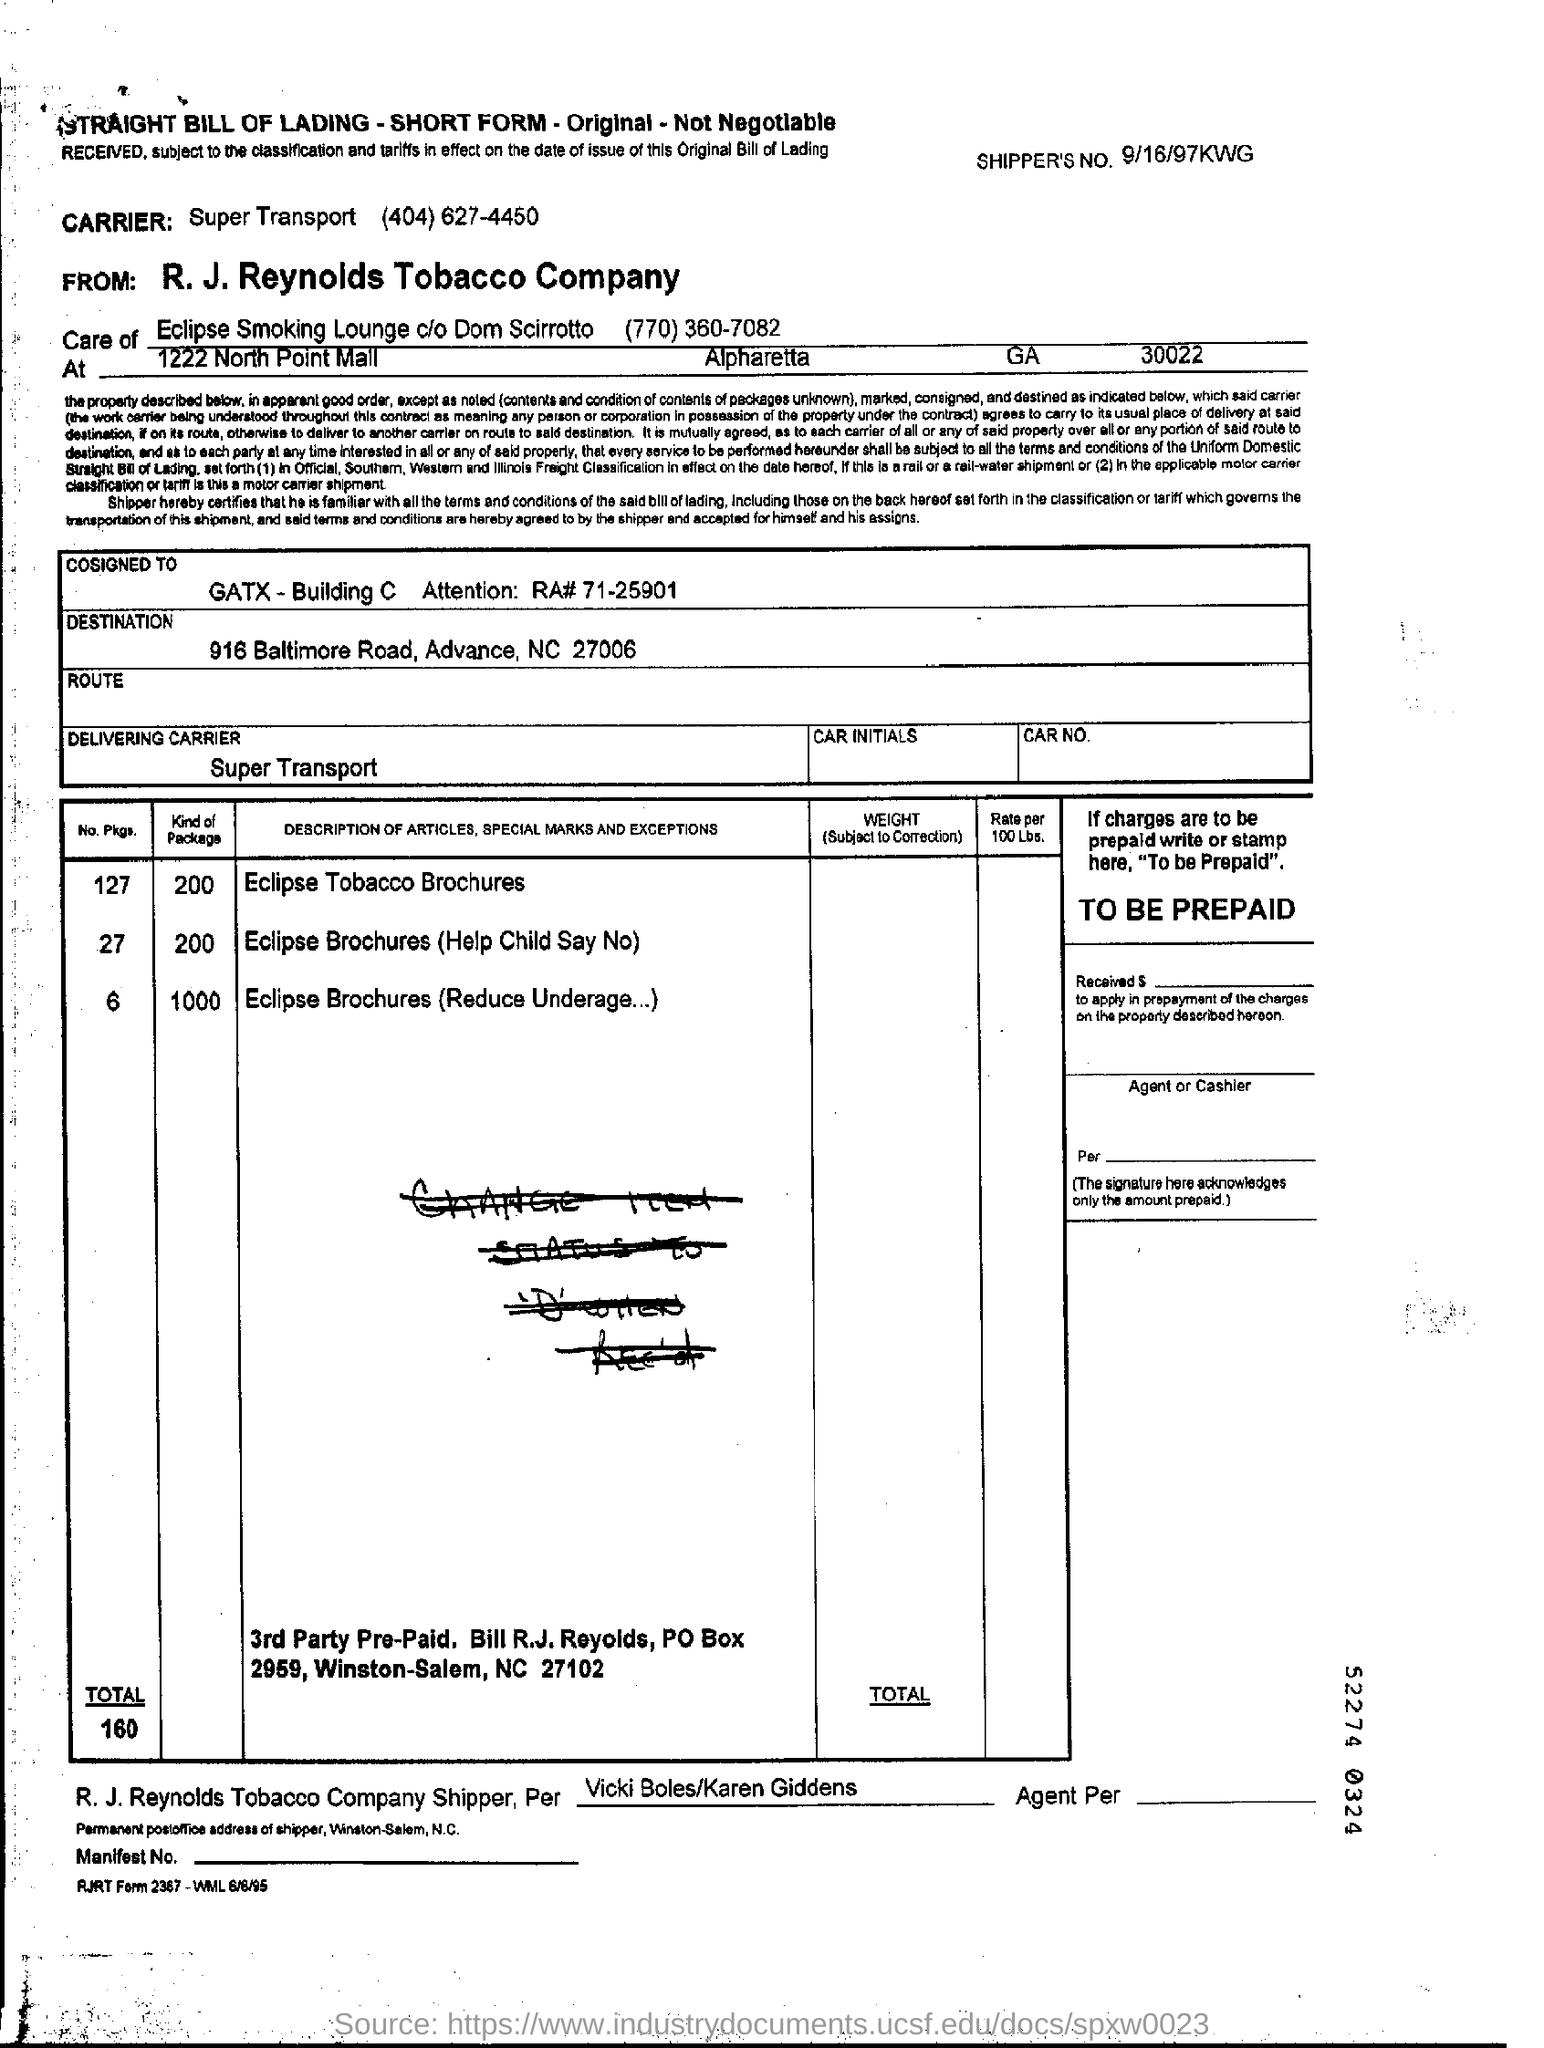Which delivering carrier is used here?
Keep it short and to the point. Super Transport (404) 627-4450. What is the shipper's no. mentioned in the form?
Your answer should be compact. 9/16/97KWG. What is the description of the first article mentioned in the table?
Your answer should be compact. Eclipse Tobacco Brochures. How many number of packages are there for the first article " Eclipse Tobacco Brochures" ?
Your response must be concise. 127. How many packages are there in total?
Ensure brevity in your answer.  160. What is the description of the second article mentioned in the table?
Your response must be concise. Eclipse Brochures (Help Child Say No). What is the description of the third article mentioned in the table?
Give a very brief answer. Eclipse Brochures (Reduce Underage...). 